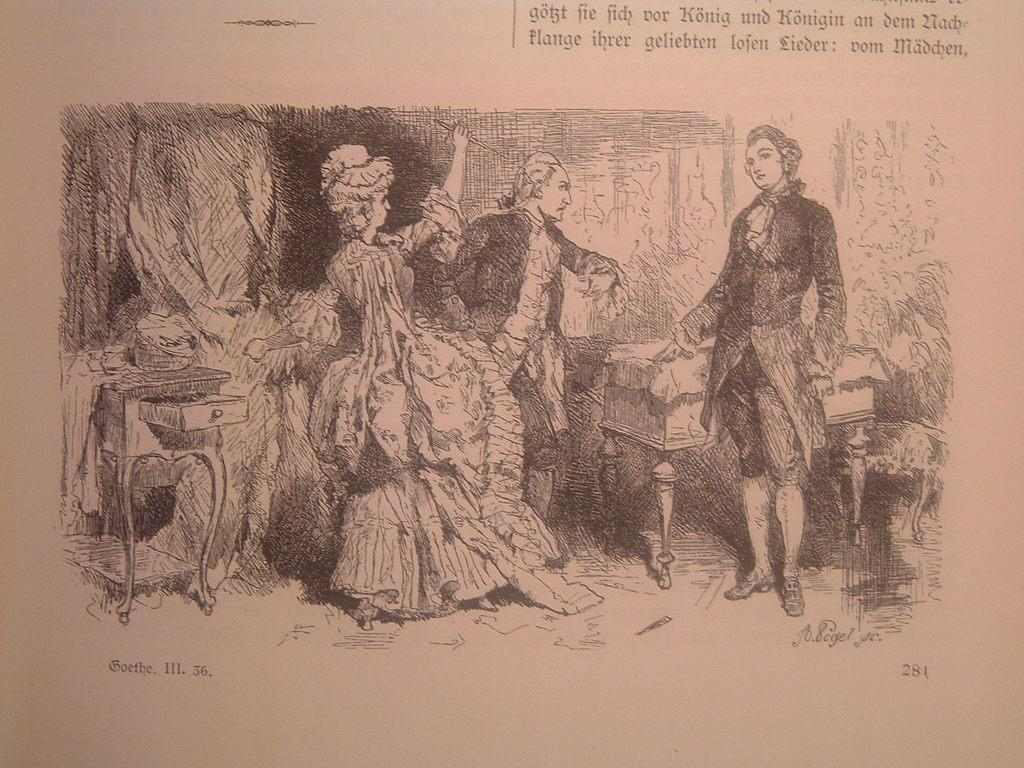What is the main subject of the image? The main subject of the image is a sketch of three persons. What else can be seen in the image besides the sketch of the three persons? There are things depicted in the image. Is there any text or writing in the image? Yes, there is writing in the image. What type of form is the aunt filling out in the image? There is no form or aunt present in the image; it is a sketch of three persons with writing. 